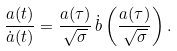Convert formula to latex. <formula><loc_0><loc_0><loc_500><loc_500>\frac { a ( t ) } { \dot { a } ( t ) } = \frac { a ( \tau ) } { \sqrt { \sigma } } \, \dot { b } \left ( \frac { a ( \tau ) } { \sqrt { \sigma } } \right ) .</formula> 